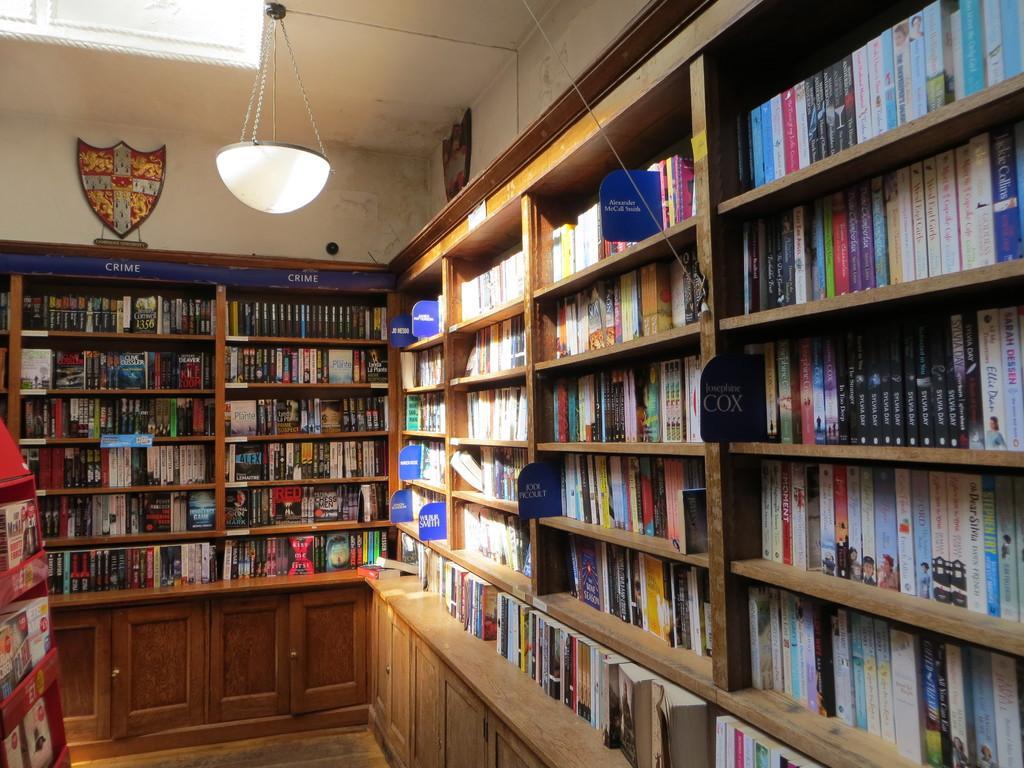Can you describe this image briefly? In this image we can see an electric light hanging from the roof, mementos attached to the walls and many books arranged in the shelves or cupboards. 